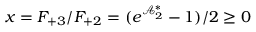Convert formula to latex. <formula><loc_0><loc_0><loc_500><loc_500>x = F _ { + 3 } / F _ { + 2 } = ( e ^ { \mathcal { A } _ { 2 } ^ { \ast } } - 1 ) / 2 \geq 0</formula> 